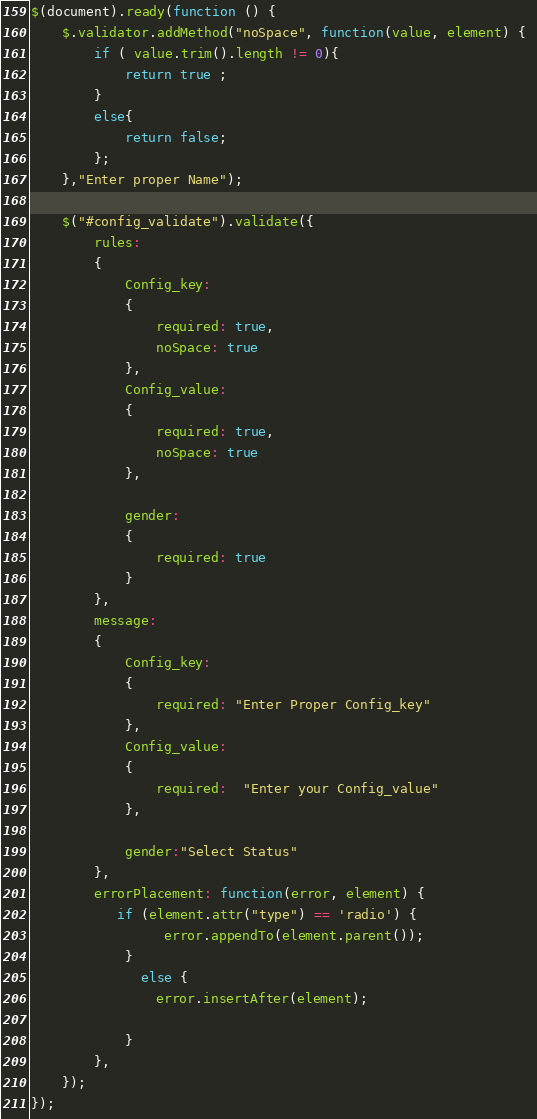Convert code to text. <code><loc_0><loc_0><loc_500><loc_500><_JavaScript_>$(document).ready(function () {
	$.validator.addMethod("noSpace", function(value, element) { 
		if ( value.trim().length != 0){ 
			return true ;
		} 
		else{
			return false;
		};
	},"Enter proper Name");

	$("#config_validate").validate({
		rules:
		{
			Config_key:
			{
				required: true,
				noSpace: true
			},
			Config_value:
			{
				required: true,
				noSpace: true
			},
			
			gender:
			{
				required: true
			}
		},
		message:
		{
			Config_key:
			{
				required: "Enter Proper Config_key"
			},
			Config_value:
			{
				required:  "Enter your Config_value"
			},
			
			gender:"Select Status"
		},
		errorPlacement: function(error, element) {
           if (element.attr("type") == 'radio') {
                 error.appendTo(element.parent());
            }
              else {
                error.insertAfter(element);

            }
        },
	});
});</code> 